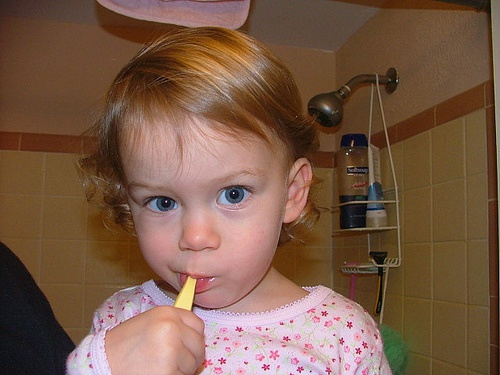Describe the objects in this image and their specific colors. I can see people in black, lightpink, gray, maroon, and lavender tones, bottle in black, maroon, and gray tones, and toothbrush in black, khaki, brown, and maroon tones in this image. 